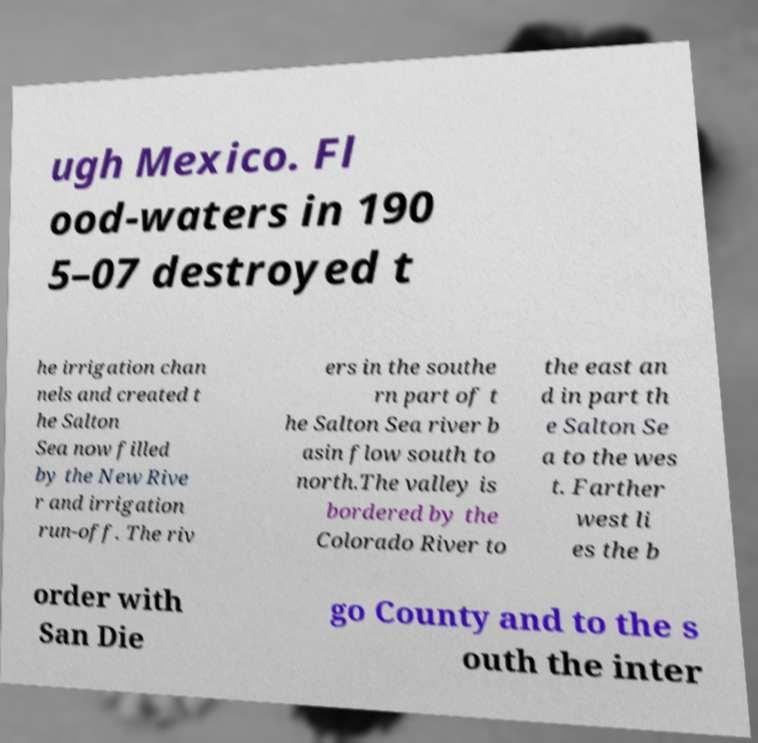Could you assist in decoding the text presented in this image and type it out clearly? ugh Mexico. Fl ood-waters in 190 5–07 destroyed t he irrigation chan nels and created t he Salton Sea now filled by the New Rive r and irrigation run-off. The riv ers in the southe rn part of t he Salton Sea river b asin flow south to north.The valley is bordered by the Colorado River to the east an d in part th e Salton Se a to the wes t. Farther west li es the b order with San Die go County and to the s outh the inter 